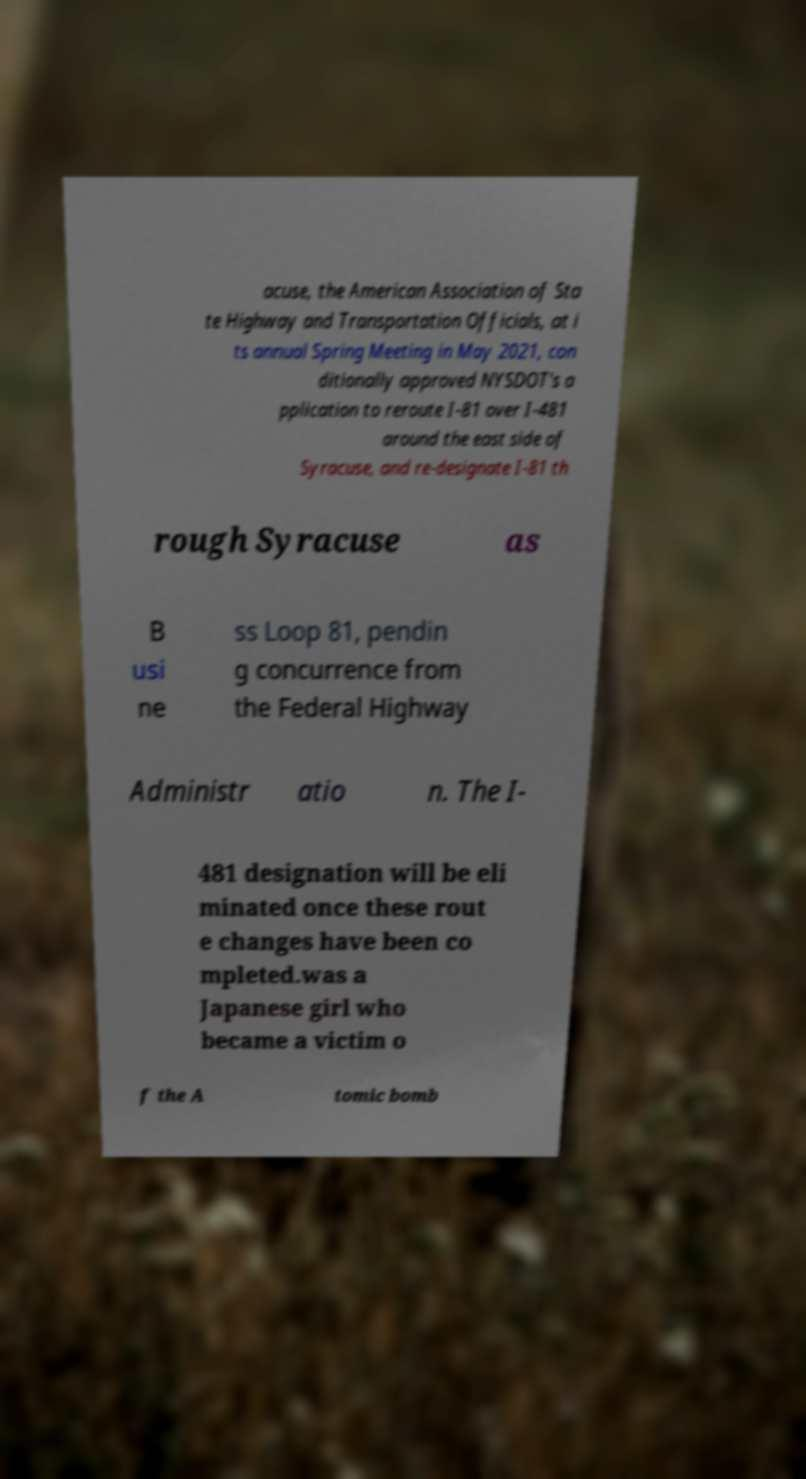Can you read and provide the text displayed in the image?This photo seems to have some interesting text. Can you extract and type it out for me? acuse, the American Association of Sta te Highway and Transportation Officials, at i ts annual Spring Meeting in May 2021, con ditionally approved NYSDOT's a pplication to reroute I-81 over I-481 around the east side of Syracuse, and re-designate I-81 th rough Syracuse as B usi ne ss Loop 81, pendin g concurrence from the Federal Highway Administr atio n. The I- 481 designation will be eli minated once these rout e changes have been co mpleted.was a Japanese girl who became a victim o f the A tomic bomb 